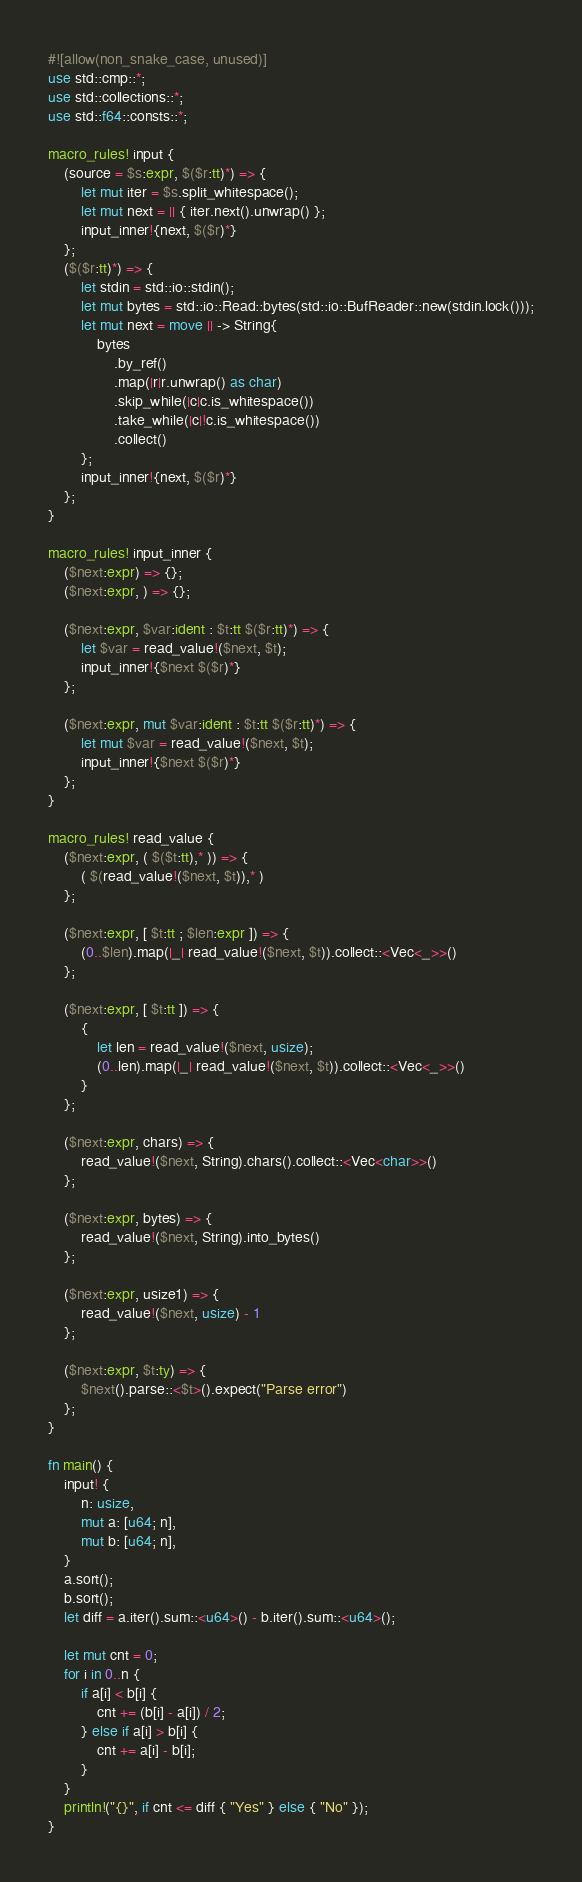Convert code to text. <code><loc_0><loc_0><loc_500><loc_500><_Rust_>#![allow(non_snake_case, unused)]
use std::cmp::*;
use std::collections::*;
use std::f64::consts::*;

macro_rules! input {
    (source = $s:expr, $($r:tt)*) => {
        let mut iter = $s.split_whitespace();
        let mut next = || { iter.next().unwrap() };
        input_inner!{next, $($r)*}
    };
    ($($r:tt)*) => {
        let stdin = std::io::stdin();
        let mut bytes = std::io::Read::bytes(std::io::BufReader::new(stdin.lock()));
        let mut next = move || -> String{
            bytes
                .by_ref()
                .map(|r|r.unwrap() as char)
                .skip_while(|c|c.is_whitespace())
                .take_while(|c|!c.is_whitespace())
                .collect()
        };
        input_inner!{next, $($r)*}
    };
}

macro_rules! input_inner {
    ($next:expr) => {};
    ($next:expr, ) => {};

    ($next:expr, $var:ident : $t:tt $($r:tt)*) => {
        let $var = read_value!($next, $t);
        input_inner!{$next $($r)*}
    };

    ($next:expr, mut $var:ident : $t:tt $($r:tt)*) => {
        let mut $var = read_value!($next, $t);
        input_inner!{$next $($r)*}
    };
}

macro_rules! read_value {
    ($next:expr, ( $($t:tt),* )) => {
        ( $(read_value!($next, $t)),* )
    };

    ($next:expr, [ $t:tt ; $len:expr ]) => {
        (0..$len).map(|_| read_value!($next, $t)).collect::<Vec<_>>()
    };

    ($next:expr, [ $t:tt ]) => {
        {
            let len = read_value!($next, usize);
            (0..len).map(|_| read_value!($next, $t)).collect::<Vec<_>>()
        }
    };

    ($next:expr, chars) => {
        read_value!($next, String).chars().collect::<Vec<char>>()
    };

    ($next:expr, bytes) => {
        read_value!($next, String).into_bytes()
    };

    ($next:expr, usize1) => {
        read_value!($next, usize) - 1
    };

    ($next:expr, $t:ty) => {
        $next().parse::<$t>().expect("Parse error")
    };
}

fn main() {
    input! {
        n: usize,
        mut a: [u64; n],
        mut b: [u64; n],
    }
    a.sort();
    b.sort();
    let diff = a.iter().sum::<u64>() - b.iter().sum::<u64>();

    let mut cnt = 0;
    for i in 0..n {
        if a[i] < b[i] {
            cnt += (b[i] - a[i]) / 2;
        } else if a[i] > b[i] {
            cnt += a[i] - b[i];
        }
    }
    println!("{}", if cnt <= diff { "Yes" } else { "No" });
}
</code> 